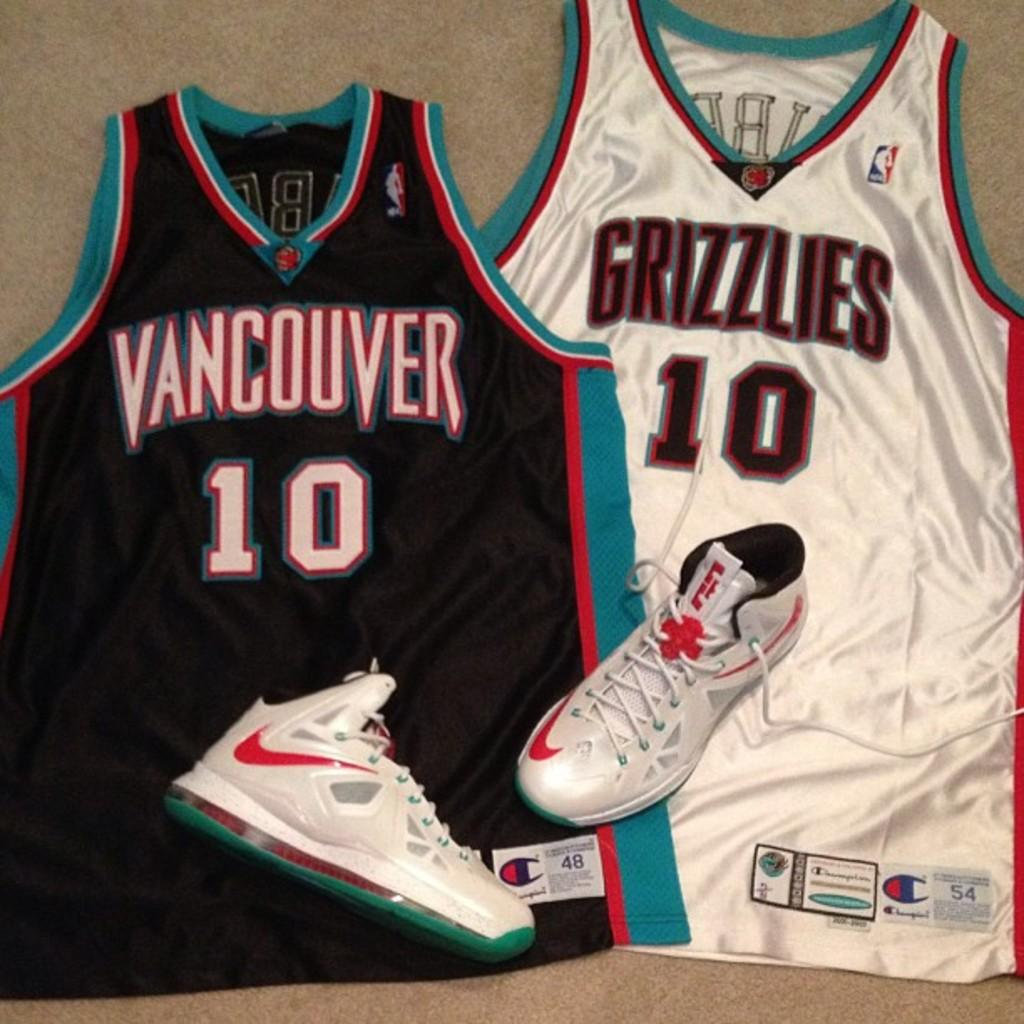<image>
Offer a succinct explanation of the picture presented. the number 10 is on the front of the jersey 